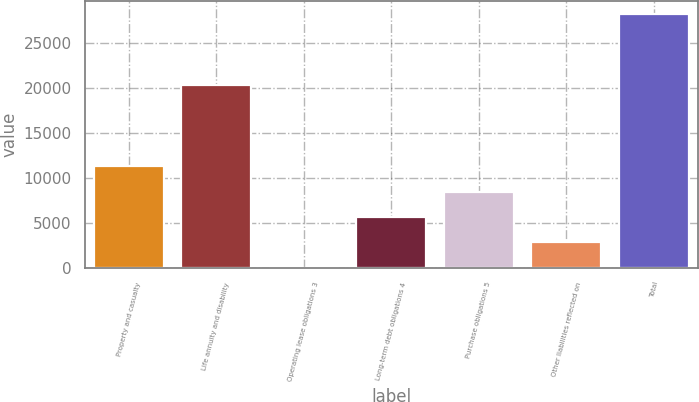Convert chart. <chart><loc_0><loc_0><loc_500><loc_500><bar_chart><fcel>Property and casualty<fcel>Life annuity and disability<fcel>Operating lease obligations 3<fcel>Long-term debt obligations 4<fcel>Purchase obligations 5<fcel>Other liabilities reflected on<fcel>Total<nl><fcel>11330<fcel>20308<fcel>42<fcel>5686<fcel>8508<fcel>2864<fcel>28262<nl></chart> 